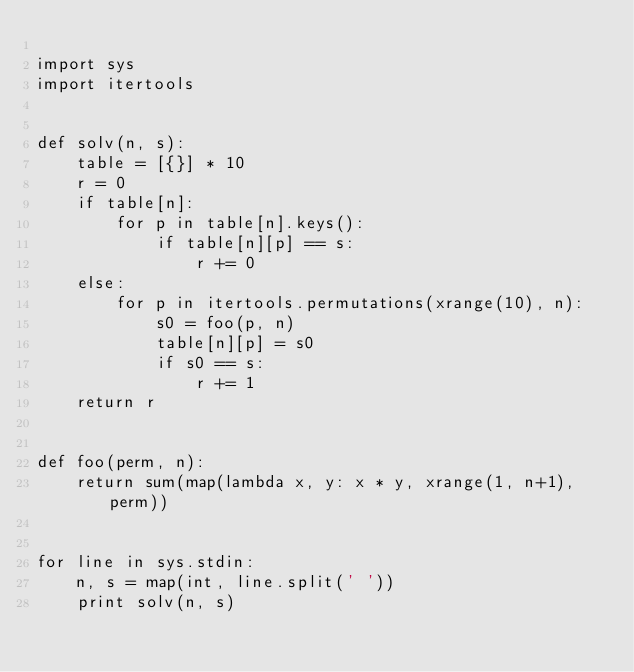<code> <loc_0><loc_0><loc_500><loc_500><_Python_>
import sys
import itertools


def solv(n, s):
    table = [{}] * 10
    r = 0
    if table[n]:
        for p in table[n].keys():
            if table[n][p] == s:
                r += 0
    else:
        for p in itertools.permutations(xrange(10), n):
            s0 = foo(p, n)
            table[n][p] = s0
            if s0 == s:
                r += 1
    return r


def foo(perm, n):
    return sum(map(lambda x, y: x * y, xrange(1, n+1), perm))


for line in sys.stdin:
    n, s = map(int, line.split(' '))
    print solv(n, s)</code> 